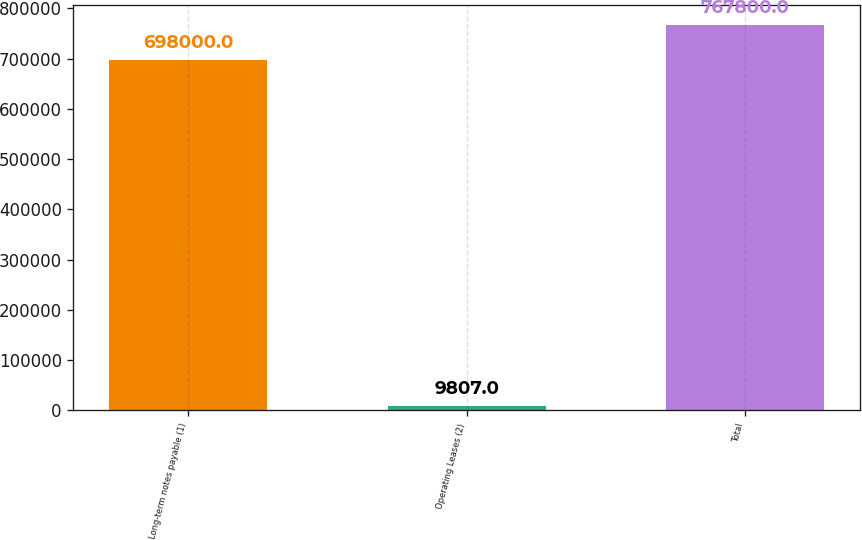<chart> <loc_0><loc_0><loc_500><loc_500><bar_chart><fcel>Long-term notes payable (1)<fcel>Operating Leases (2)<fcel>Total<nl><fcel>698000<fcel>9807<fcel>767800<nl></chart> 